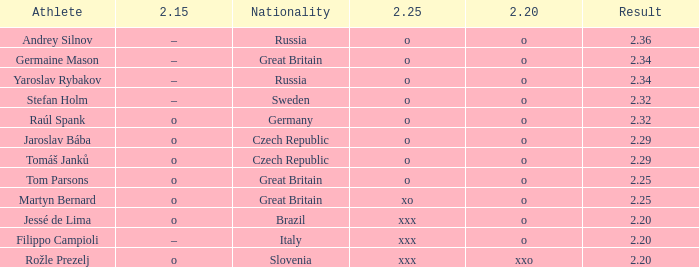Which athlete from Germany has 2.20 of O and a 2.25 of O? Raúl Spank. 